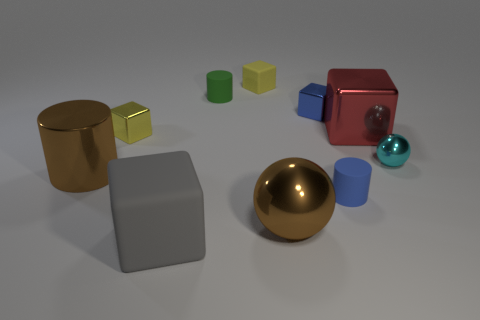Subtract 1 cubes. How many cubes are left? 4 Subtract all red cubes. Subtract all green balls. How many cubes are left? 4 Subtract all cylinders. How many objects are left? 7 Add 3 big red things. How many big red things are left? 4 Add 9 gray objects. How many gray objects exist? 10 Subtract 1 gray blocks. How many objects are left? 9 Subtract all yellow objects. Subtract all cylinders. How many objects are left? 5 